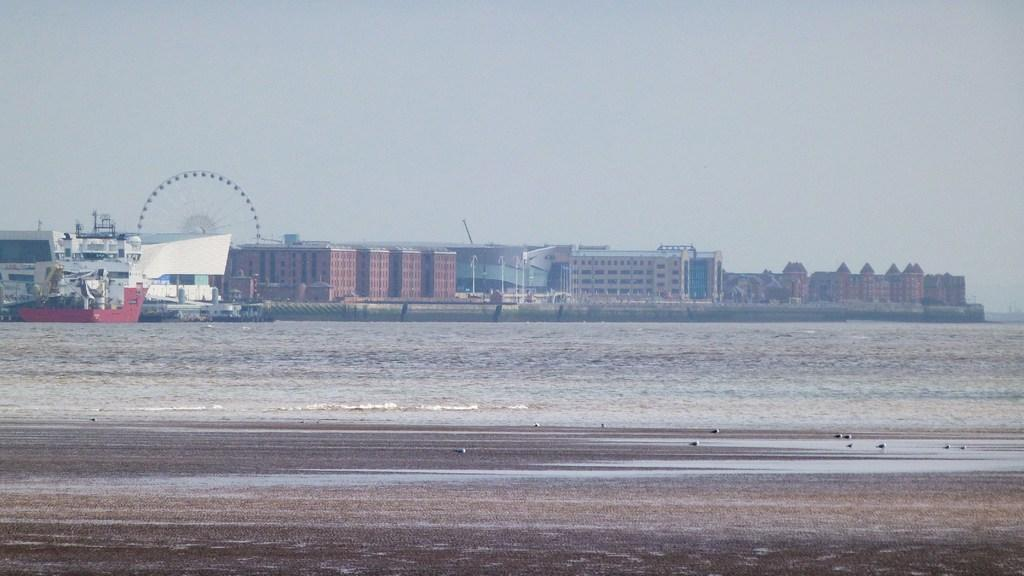What is the main subject of the image? The main subject of the image is ships on the ocean. What else can be seen in the image besides the ships? There are buildings, poles, a giant wheel, birds on the ground, and the sky visible in the image. Can you describe the giant wheel in the image? Yes, there is a giant wheel present in the image. What type of birds are on the ground in the image? The facts provided do not specify the type of birds on the ground. What type of noise can be heard coming from the bottle in the image? There is no bottle present in the image, so it is not possible to determine what noise might be heard. 